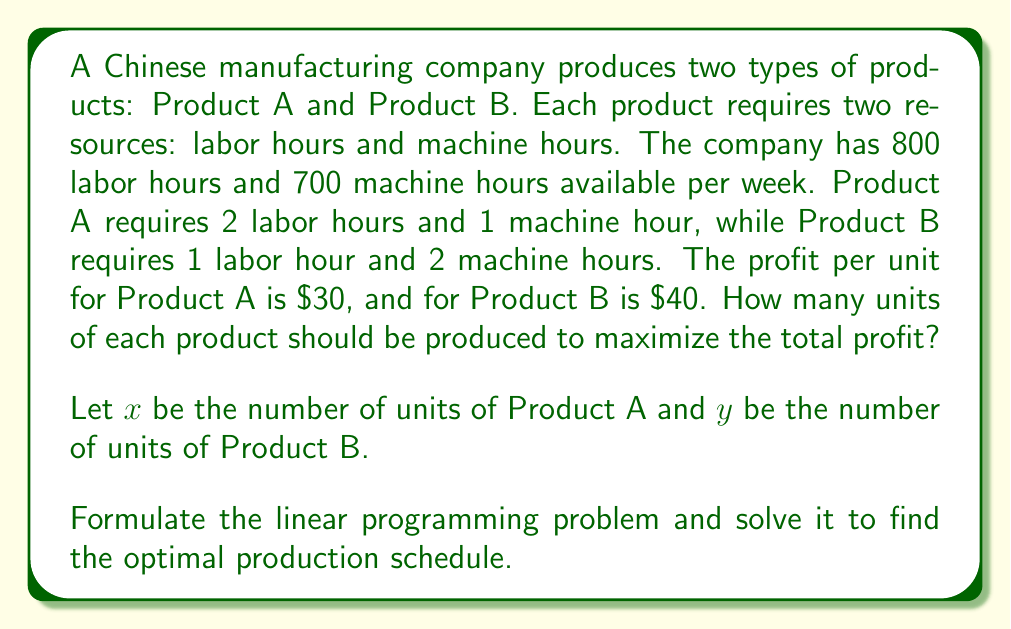Help me with this question. To solve this linear programming problem, we'll follow these steps:

1. Formulate the objective function:
   Maximize profit: $P = 30x + 40y$

2. Identify the constraints:
   Labor hours: $2x + y \leq 800$
   Machine hours: $x + 2y \leq 700$
   Non-negativity: $x \geq 0$, $y \geq 0$

3. Graph the constraints:
   [asy]
   import geometry;
   
   size(200);
   
   xaxis("x", 0, 800, Arrow);
   yaxis("y", 0, 800, Arrow);
   
   draw((0,800)--(400,0), blue);
   draw((0,350)--(700,0), red);
   
   label("2x + y = 800", (200,400), NE, blue);
   label("x + 2y = 700", (350,175), SE, red);
   
   dot((300,200), red);
   label("(300, 200)", (300,200), NE);
   
   dot((400,0), green);
   label("(400, 0)", (400,0), SW);
   
   dot((0,350), green);
   label("(0, 350)", (0,350), W);
   
   filldraw((0,0)--(400,0)--(300,200)--(0,350)--cycle, palegreen, black);
   [/asy]

4. Identify the corner points:
   (0, 0), (400, 0), (300, 200), (0, 350)

5. Evaluate the objective function at each corner point:
   P(0, 0) = 0
   P(400, 0) = 30(400) + 40(0) = 12,000
   P(300, 200) = 30(300) + 40(200) = 17,000
   P(0, 350) = 30(0) + 40(350) = 14,000

6. The maximum profit occurs at the point (300, 200).

Therefore, the optimal production schedule is to produce 300 units of Product A and 200 units of Product B, resulting in a maximum profit of $17,000.
Answer: 300 units of Product A, 200 units of Product B 